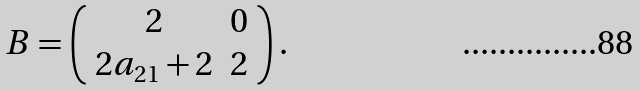Convert formula to latex. <formula><loc_0><loc_0><loc_500><loc_500>B = \left ( \begin{array} { c r } 2 & 0 \\ 2 a _ { 2 1 } + 2 & 2 \\ \end{array} \right ) .</formula> 